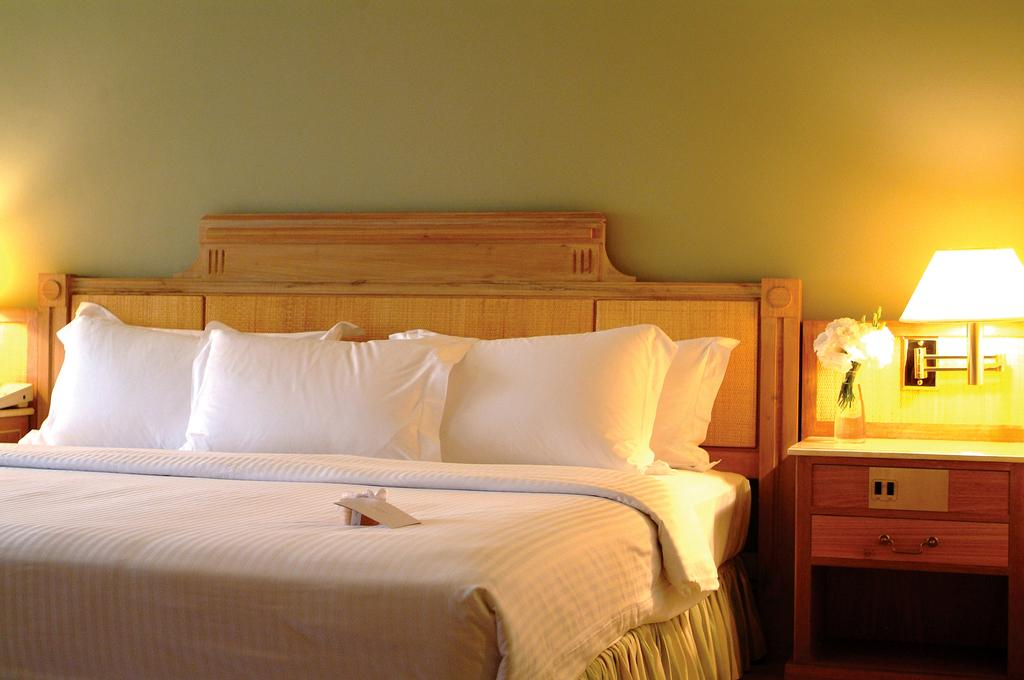What piece of furniture is the main subject in the image? There is a bed in the image. How many pillows are on the bed? There are three pillows on the bed. What other piece of furniture is visible in the image? There is a cupboard in the image. What is placed on top of the cupboard? A lamp is present on the cupboard. What can be seen in the background of the image? There is a wall visible in the background of the image. What type of ladybug can be seen crawling on the wall in the image? There is no ladybug present in the image; only a bed, pillows, cupboard, lamp, and wall are visible. 